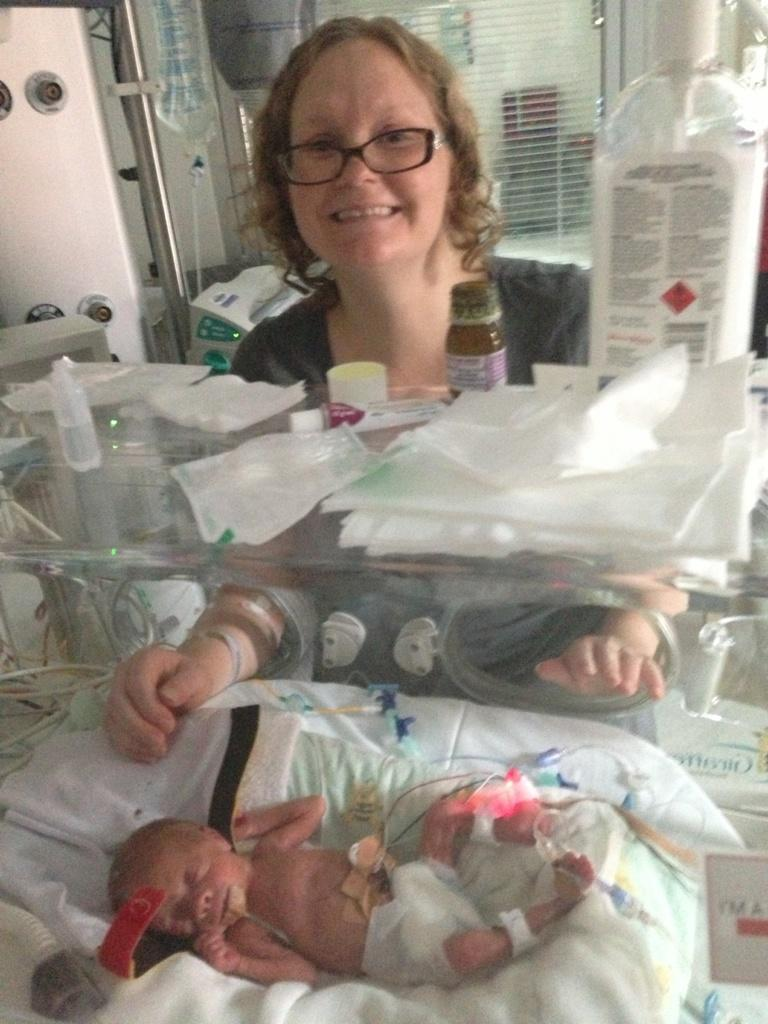What is the baby laying on in the image? The baby is laying on a cushion inside an incubator. What items can be seen in the image besides the baby? There are bottles, papers, napkins, and an iron rod in the image. What is the person in the image doing? The person is standing and smiling in the image. What might be used for cleaning or wiping in the image? Napkins are present in the image for cleaning or wiping. What type of crook can be seen holding a drum in the image? There is no crook or drum present in the image. What kind of structure is visible in the background of the image? The provided facts do not mention any structure in the background of the image. 